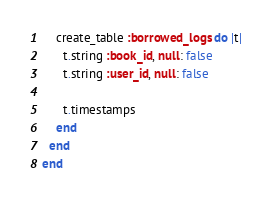Convert code to text. <code><loc_0><loc_0><loc_500><loc_500><_Ruby_>    create_table :borrowed_logs do |t|
      t.string :book_id, null: false
      t.string :user_id, null: false

      t.timestamps
    end
  end
end
</code> 